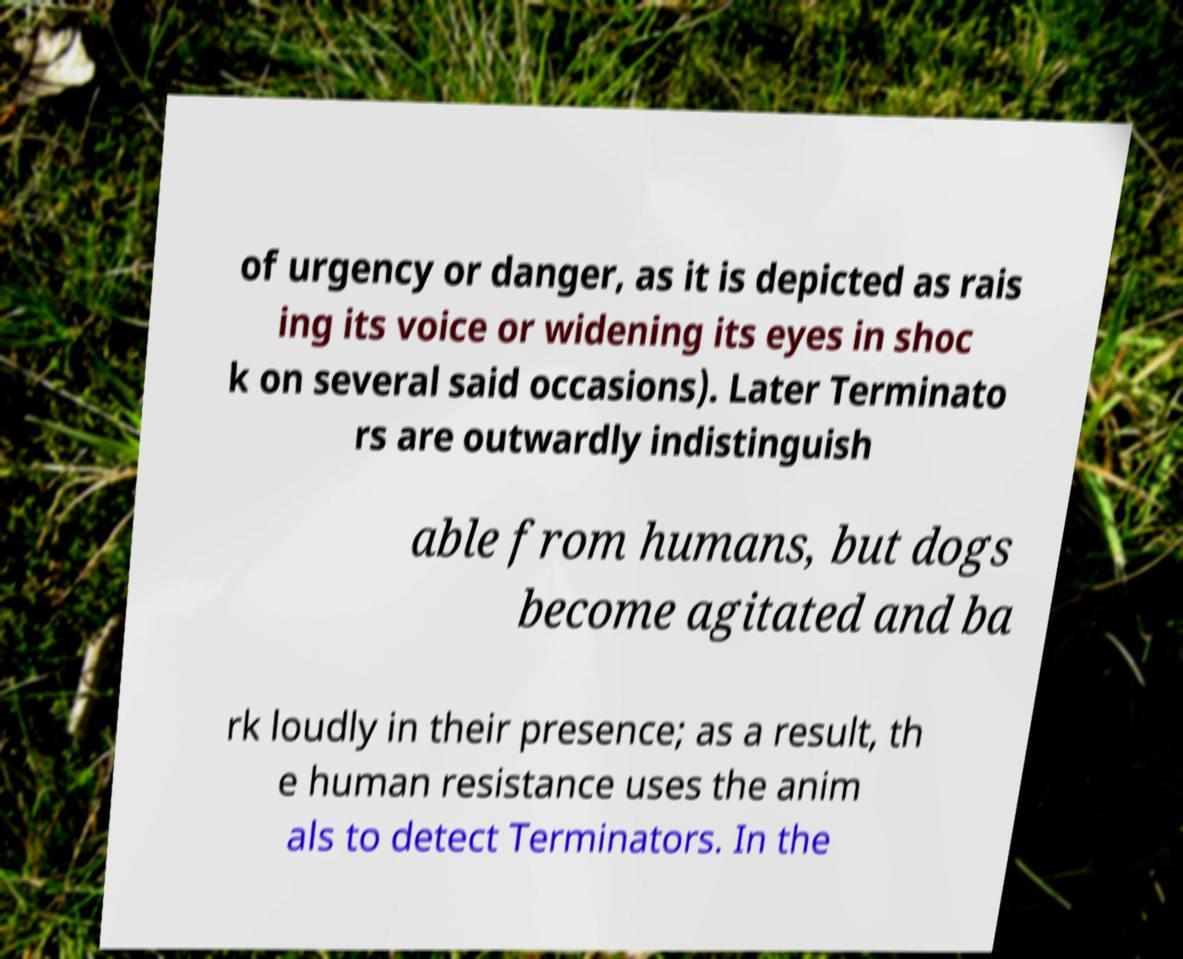Please read and relay the text visible in this image. What does it say? of urgency or danger, as it is depicted as rais ing its voice or widening its eyes in shoc k on several said occasions). Later Terminato rs are outwardly indistinguish able from humans, but dogs become agitated and ba rk loudly in their presence; as a result, th e human resistance uses the anim als to detect Terminators. In the 